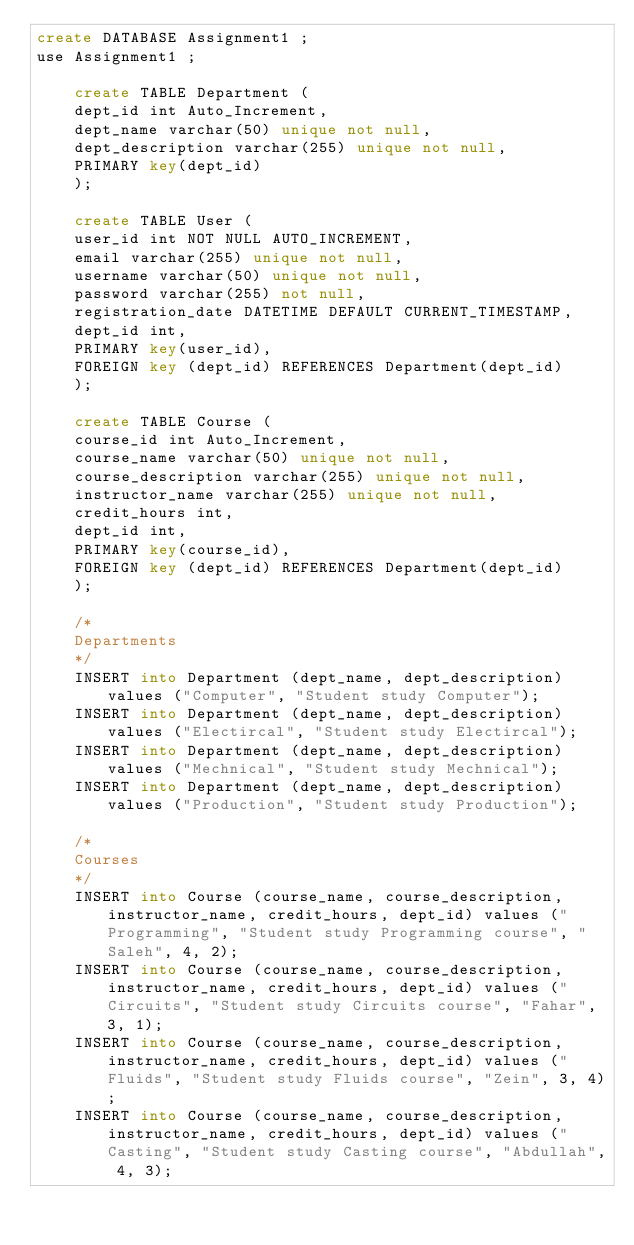<code> <loc_0><loc_0><loc_500><loc_500><_SQL_>create DATABASE Assignment1 ;
use Assignment1 ;

	create TABLE Department (
	dept_id int Auto_Increment,
	dept_name varchar(50) unique not null,
	dept_description varchar(255) unique not null,
	PRIMARY key(dept_id)
	);

	create TABLE User (
	user_id int NOT NULL AUTO_INCREMENT,
	email varchar(255) unique not null, 
	username varchar(50) unique not null,
	password varchar(255) not null,
	registration_date DATETIME DEFAULT CURRENT_TIMESTAMP,
	dept_id int,
	PRIMARY key(user_id),
	FOREIGN key (dept_id) REFERENCES Department(dept_id)
	);
	
	create TABLE Course (
	course_id int Auto_Increment,
	course_name varchar(50) unique not null,
	course_description varchar(255) unique not null,
	instructor_name varchar(255) unique not null,
	credit_hours int,
	dept_id int,
	PRIMARY key(course_id),
	FOREIGN key (dept_id) REFERENCES Department(dept_id)
	);
	
	/*
	Departments
	*/
	INSERT into Department (dept_name, dept_description) values ("Computer", "Student study Computer");
	INSERT into Department (dept_name, dept_description) values ("Electircal", "Student study Electircal");
	INSERT into Department (dept_name, dept_description) values ("Mechnical", "Student study Mechnical");
	INSERT into Department (dept_name, dept_description) values ("Production", "Student study Production");
	
	/*
	Courses
	*/
	INSERT into Course (course_name, course_description, instructor_name, credit_hours, dept_id) values ("Programming", "Student study Programming course", "Saleh", 4, 2);
	INSERT into Course (course_name, course_description, instructor_name, credit_hours, dept_id) values ("Circuits", "Student study Circuits course", "Fahar", 3, 1);
	INSERT into Course (course_name, course_description, instructor_name, credit_hours, dept_id) values ("Fluids", "Student study Fluids course", "Zein", 3, 4);
	INSERT into Course (course_name, course_description, instructor_name, credit_hours, dept_id) values ("Casting", "Student study Casting course", "Abdullah", 4, 3);	
	
	</code> 